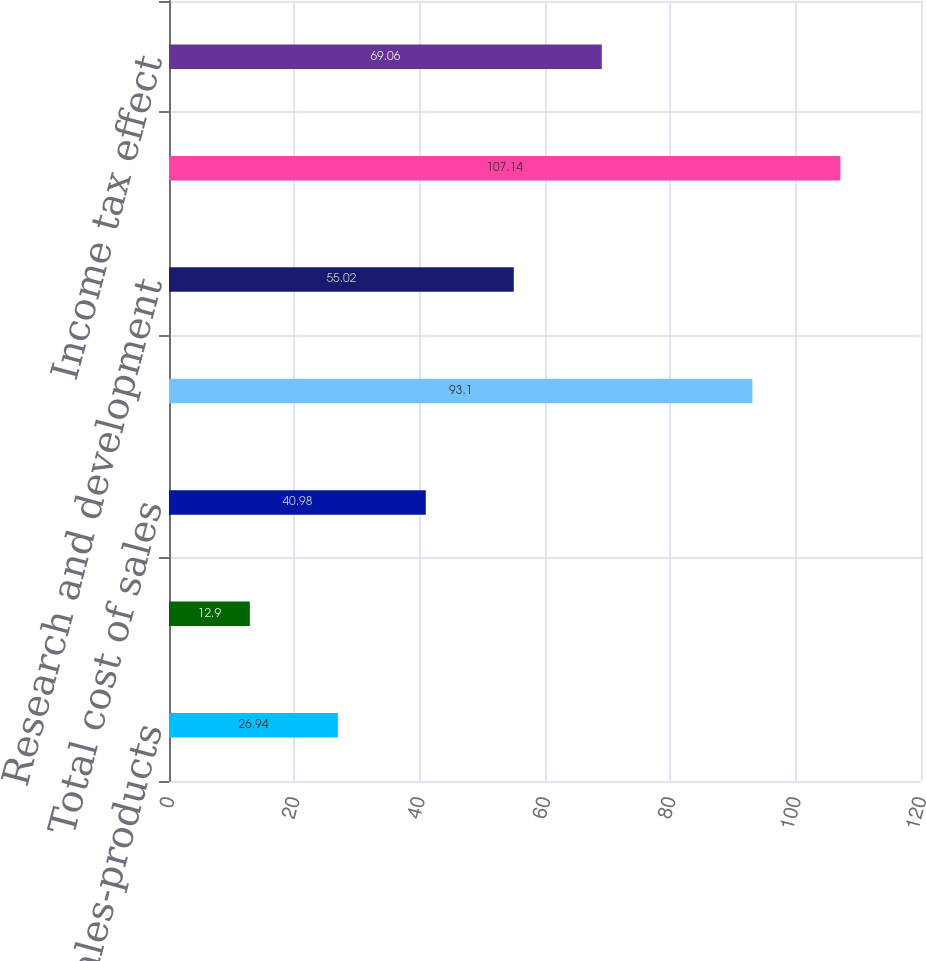Convert chart to OTSL. <chart><loc_0><loc_0><loc_500><loc_500><bar_chart><fcel>Cost of sales-products<fcel>Cost of sales-services<fcel>Total cost of sales<fcel>Selling general and<fcel>Research and development<fcel>Stock-based compensation<fcel>Income tax effect<nl><fcel>26.94<fcel>12.9<fcel>40.98<fcel>93.1<fcel>55.02<fcel>107.14<fcel>69.06<nl></chart> 